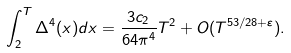<formula> <loc_0><loc_0><loc_500><loc_500>\int _ { 2 } ^ { T } \Delta ^ { 4 } ( x ) d x = \frac { 3 c _ { 2 } } { 6 4 \pi ^ { 4 } } T ^ { 2 } + O ( T ^ { 5 3 / 2 8 + \varepsilon } ) .</formula> 